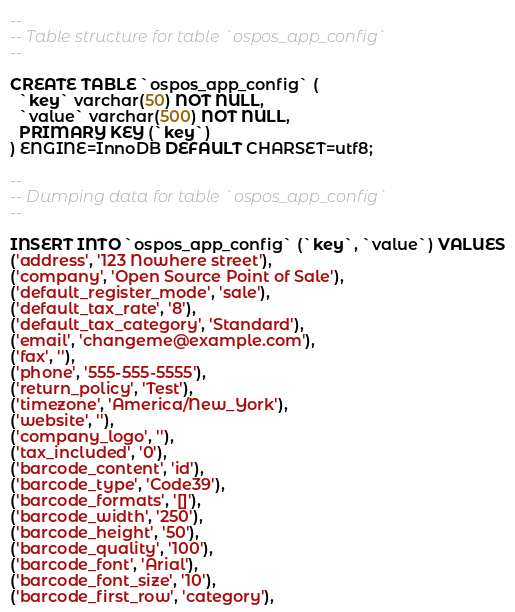<code> <loc_0><loc_0><loc_500><loc_500><_SQL_>
--
-- Table structure for table `ospos_app_config`
--

CREATE TABLE `ospos_app_config` (
  `key` varchar(50) NOT NULL,
  `value` varchar(500) NOT NULL,
  PRIMARY KEY (`key`)
) ENGINE=InnoDB DEFAULT CHARSET=utf8;

--
-- Dumping data for table `ospos_app_config`
--

INSERT INTO `ospos_app_config` (`key`, `value`) VALUES
('address', '123 Nowhere street'),
('company', 'Open Source Point of Sale'),
('default_register_mode', 'sale'),
('default_tax_rate', '8'),
('default_tax_category', 'Standard'),
('email', 'changeme@example.com'),
('fax', ''),
('phone', '555-555-5555'),
('return_policy', 'Test'),
('timezone', 'America/New_York'),
('website', ''),
('company_logo', ''),
('tax_included', '0'),
('barcode_content', 'id'),
('barcode_type', 'Code39'),
('barcode_formats', '[]'),
('barcode_width', '250'),
('barcode_height', '50'),
('barcode_quality', '100'),
('barcode_font', 'Arial'),
('barcode_font_size', '10'),
('barcode_first_row', 'category'),</code> 